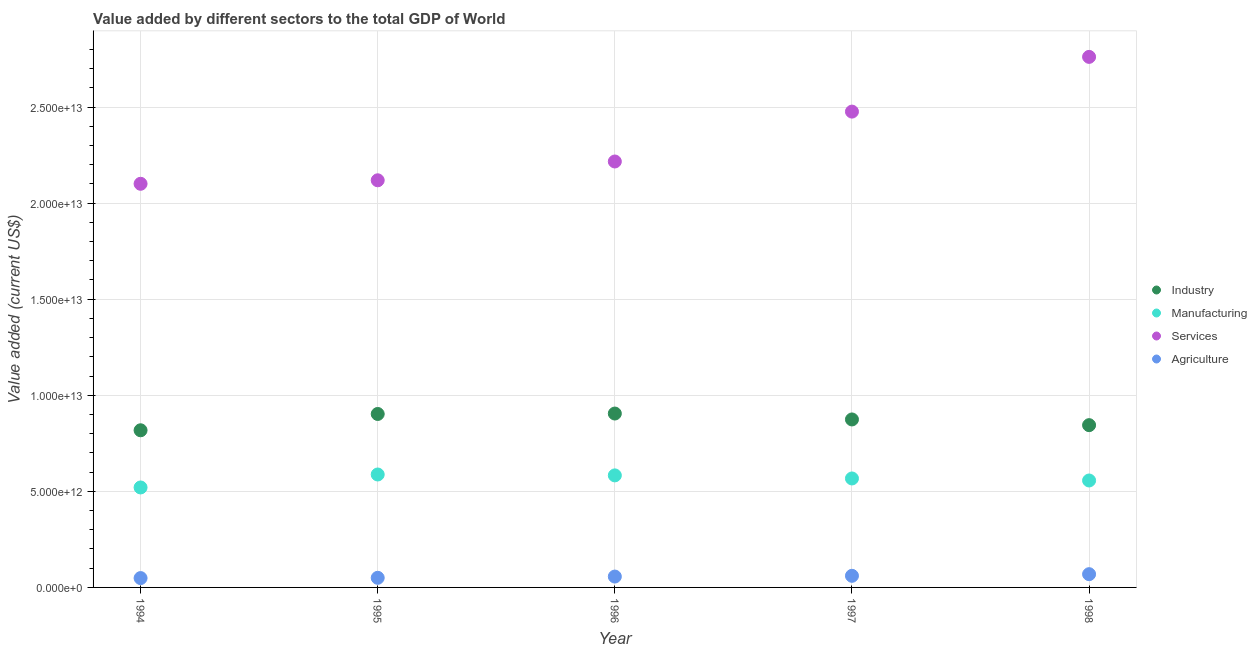How many different coloured dotlines are there?
Your answer should be very brief. 4. What is the value added by agricultural sector in 1995?
Your answer should be compact. 5.00e+11. Across all years, what is the maximum value added by services sector?
Provide a short and direct response. 2.76e+13. Across all years, what is the minimum value added by agricultural sector?
Offer a very short reply. 4.86e+11. In which year was the value added by manufacturing sector maximum?
Provide a short and direct response. 1995. In which year was the value added by manufacturing sector minimum?
Your response must be concise. 1994. What is the total value added by services sector in the graph?
Provide a short and direct response. 1.17e+14. What is the difference between the value added by manufacturing sector in 1994 and that in 1998?
Offer a terse response. -3.63e+11. What is the difference between the value added by agricultural sector in 1998 and the value added by services sector in 1995?
Provide a short and direct response. -2.05e+13. What is the average value added by manufacturing sector per year?
Make the answer very short. 5.63e+12. In the year 1996, what is the difference between the value added by industrial sector and value added by services sector?
Make the answer very short. -1.31e+13. What is the ratio of the value added by agricultural sector in 1994 to that in 1998?
Offer a terse response. 0.71. Is the value added by agricultural sector in 1997 less than that in 1998?
Offer a very short reply. Yes. What is the difference between the highest and the second highest value added by services sector?
Offer a very short reply. 2.85e+12. What is the difference between the highest and the lowest value added by agricultural sector?
Offer a very short reply. 2.03e+11. Is the value added by agricultural sector strictly less than the value added by services sector over the years?
Keep it short and to the point. Yes. What is the difference between two consecutive major ticks on the Y-axis?
Offer a very short reply. 5.00e+12. Are the values on the major ticks of Y-axis written in scientific E-notation?
Offer a very short reply. Yes. Does the graph contain any zero values?
Provide a succinct answer. No. Does the graph contain grids?
Your response must be concise. Yes. How are the legend labels stacked?
Your answer should be compact. Vertical. What is the title of the graph?
Your answer should be compact. Value added by different sectors to the total GDP of World. What is the label or title of the Y-axis?
Provide a short and direct response. Value added (current US$). What is the Value added (current US$) of Industry in 1994?
Offer a very short reply. 8.18e+12. What is the Value added (current US$) of Manufacturing in 1994?
Offer a terse response. 5.20e+12. What is the Value added (current US$) in Services in 1994?
Your answer should be compact. 2.10e+13. What is the Value added (current US$) of Agriculture in 1994?
Make the answer very short. 4.86e+11. What is the Value added (current US$) of Industry in 1995?
Give a very brief answer. 9.03e+12. What is the Value added (current US$) in Manufacturing in 1995?
Offer a terse response. 5.88e+12. What is the Value added (current US$) in Services in 1995?
Your answer should be very brief. 2.12e+13. What is the Value added (current US$) of Agriculture in 1995?
Keep it short and to the point. 5.00e+11. What is the Value added (current US$) of Industry in 1996?
Provide a short and direct response. 9.05e+12. What is the Value added (current US$) in Manufacturing in 1996?
Your answer should be very brief. 5.83e+12. What is the Value added (current US$) in Services in 1996?
Offer a very short reply. 2.22e+13. What is the Value added (current US$) in Agriculture in 1996?
Your answer should be very brief. 5.66e+11. What is the Value added (current US$) in Industry in 1997?
Give a very brief answer. 8.74e+12. What is the Value added (current US$) of Manufacturing in 1997?
Make the answer very short. 5.67e+12. What is the Value added (current US$) in Services in 1997?
Provide a succinct answer. 2.48e+13. What is the Value added (current US$) in Agriculture in 1997?
Offer a very short reply. 6.04e+11. What is the Value added (current US$) of Industry in 1998?
Ensure brevity in your answer.  8.45e+12. What is the Value added (current US$) in Manufacturing in 1998?
Your answer should be compact. 5.57e+12. What is the Value added (current US$) in Services in 1998?
Give a very brief answer. 2.76e+13. What is the Value added (current US$) in Agriculture in 1998?
Your response must be concise. 6.90e+11. Across all years, what is the maximum Value added (current US$) in Industry?
Your answer should be very brief. 9.05e+12. Across all years, what is the maximum Value added (current US$) in Manufacturing?
Provide a succinct answer. 5.88e+12. Across all years, what is the maximum Value added (current US$) of Services?
Your answer should be compact. 2.76e+13. Across all years, what is the maximum Value added (current US$) of Agriculture?
Provide a succinct answer. 6.90e+11. Across all years, what is the minimum Value added (current US$) in Industry?
Your answer should be compact. 8.18e+12. Across all years, what is the minimum Value added (current US$) of Manufacturing?
Ensure brevity in your answer.  5.20e+12. Across all years, what is the minimum Value added (current US$) in Services?
Your response must be concise. 2.10e+13. Across all years, what is the minimum Value added (current US$) in Agriculture?
Your response must be concise. 4.86e+11. What is the total Value added (current US$) of Industry in the graph?
Your answer should be very brief. 4.34e+13. What is the total Value added (current US$) of Manufacturing in the graph?
Your answer should be compact. 2.81e+13. What is the total Value added (current US$) in Services in the graph?
Your answer should be very brief. 1.17e+14. What is the total Value added (current US$) of Agriculture in the graph?
Offer a very short reply. 2.85e+12. What is the difference between the Value added (current US$) of Industry in 1994 and that in 1995?
Ensure brevity in your answer.  -8.49e+11. What is the difference between the Value added (current US$) in Manufacturing in 1994 and that in 1995?
Your response must be concise. -6.75e+11. What is the difference between the Value added (current US$) in Services in 1994 and that in 1995?
Offer a terse response. -1.82e+11. What is the difference between the Value added (current US$) in Agriculture in 1994 and that in 1995?
Offer a terse response. -1.42e+1. What is the difference between the Value added (current US$) in Industry in 1994 and that in 1996?
Your answer should be very brief. -8.71e+11. What is the difference between the Value added (current US$) of Manufacturing in 1994 and that in 1996?
Offer a very short reply. -6.28e+11. What is the difference between the Value added (current US$) of Services in 1994 and that in 1996?
Provide a succinct answer. -1.16e+12. What is the difference between the Value added (current US$) in Agriculture in 1994 and that in 1996?
Your answer should be very brief. -7.93e+1. What is the difference between the Value added (current US$) of Industry in 1994 and that in 1997?
Your answer should be compact. -5.64e+11. What is the difference between the Value added (current US$) in Manufacturing in 1994 and that in 1997?
Provide a succinct answer. -4.68e+11. What is the difference between the Value added (current US$) in Services in 1994 and that in 1997?
Your answer should be very brief. -3.76e+12. What is the difference between the Value added (current US$) of Agriculture in 1994 and that in 1997?
Give a very brief answer. -1.18e+11. What is the difference between the Value added (current US$) in Industry in 1994 and that in 1998?
Provide a short and direct response. -2.67e+11. What is the difference between the Value added (current US$) in Manufacturing in 1994 and that in 1998?
Provide a short and direct response. -3.63e+11. What is the difference between the Value added (current US$) in Services in 1994 and that in 1998?
Give a very brief answer. -6.60e+12. What is the difference between the Value added (current US$) in Agriculture in 1994 and that in 1998?
Keep it short and to the point. -2.03e+11. What is the difference between the Value added (current US$) of Industry in 1995 and that in 1996?
Give a very brief answer. -2.27e+1. What is the difference between the Value added (current US$) in Manufacturing in 1995 and that in 1996?
Your answer should be very brief. 4.64e+1. What is the difference between the Value added (current US$) of Services in 1995 and that in 1996?
Your answer should be very brief. -9.78e+11. What is the difference between the Value added (current US$) in Agriculture in 1995 and that in 1996?
Make the answer very short. -6.51e+1. What is the difference between the Value added (current US$) in Industry in 1995 and that in 1997?
Offer a terse response. 2.85e+11. What is the difference between the Value added (current US$) of Manufacturing in 1995 and that in 1997?
Give a very brief answer. 2.07e+11. What is the difference between the Value added (current US$) of Services in 1995 and that in 1997?
Make the answer very short. -3.57e+12. What is the difference between the Value added (current US$) in Agriculture in 1995 and that in 1997?
Your answer should be very brief. -1.04e+11. What is the difference between the Value added (current US$) in Industry in 1995 and that in 1998?
Offer a very short reply. 5.82e+11. What is the difference between the Value added (current US$) of Manufacturing in 1995 and that in 1998?
Offer a terse response. 3.12e+11. What is the difference between the Value added (current US$) of Services in 1995 and that in 1998?
Ensure brevity in your answer.  -6.42e+12. What is the difference between the Value added (current US$) of Agriculture in 1995 and that in 1998?
Keep it short and to the point. -1.89e+11. What is the difference between the Value added (current US$) of Industry in 1996 and that in 1997?
Offer a terse response. 3.08e+11. What is the difference between the Value added (current US$) in Manufacturing in 1996 and that in 1997?
Ensure brevity in your answer.  1.60e+11. What is the difference between the Value added (current US$) of Services in 1996 and that in 1997?
Keep it short and to the point. -2.60e+12. What is the difference between the Value added (current US$) in Agriculture in 1996 and that in 1997?
Provide a succinct answer. -3.88e+1. What is the difference between the Value added (current US$) in Industry in 1996 and that in 1998?
Offer a very short reply. 6.05e+11. What is the difference between the Value added (current US$) of Manufacturing in 1996 and that in 1998?
Ensure brevity in your answer.  2.66e+11. What is the difference between the Value added (current US$) of Services in 1996 and that in 1998?
Your answer should be very brief. -5.44e+12. What is the difference between the Value added (current US$) in Agriculture in 1996 and that in 1998?
Offer a terse response. -1.24e+11. What is the difference between the Value added (current US$) of Industry in 1997 and that in 1998?
Keep it short and to the point. 2.97e+11. What is the difference between the Value added (current US$) in Manufacturing in 1997 and that in 1998?
Provide a short and direct response. 1.05e+11. What is the difference between the Value added (current US$) in Services in 1997 and that in 1998?
Your answer should be compact. -2.85e+12. What is the difference between the Value added (current US$) of Agriculture in 1997 and that in 1998?
Give a very brief answer. -8.53e+1. What is the difference between the Value added (current US$) of Industry in 1994 and the Value added (current US$) of Manufacturing in 1995?
Ensure brevity in your answer.  2.30e+12. What is the difference between the Value added (current US$) of Industry in 1994 and the Value added (current US$) of Services in 1995?
Provide a succinct answer. -1.30e+13. What is the difference between the Value added (current US$) in Industry in 1994 and the Value added (current US$) in Agriculture in 1995?
Make the answer very short. 7.68e+12. What is the difference between the Value added (current US$) of Manufacturing in 1994 and the Value added (current US$) of Services in 1995?
Provide a succinct answer. -1.60e+13. What is the difference between the Value added (current US$) in Manufacturing in 1994 and the Value added (current US$) in Agriculture in 1995?
Keep it short and to the point. 4.70e+12. What is the difference between the Value added (current US$) of Services in 1994 and the Value added (current US$) of Agriculture in 1995?
Your answer should be compact. 2.05e+13. What is the difference between the Value added (current US$) in Industry in 1994 and the Value added (current US$) in Manufacturing in 1996?
Your answer should be very brief. 2.35e+12. What is the difference between the Value added (current US$) in Industry in 1994 and the Value added (current US$) in Services in 1996?
Your answer should be compact. -1.40e+13. What is the difference between the Value added (current US$) of Industry in 1994 and the Value added (current US$) of Agriculture in 1996?
Your response must be concise. 7.61e+12. What is the difference between the Value added (current US$) in Manufacturing in 1994 and the Value added (current US$) in Services in 1996?
Make the answer very short. -1.70e+13. What is the difference between the Value added (current US$) of Manufacturing in 1994 and the Value added (current US$) of Agriculture in 1996?
Keep it short and to the point. 4.64e+12. What is the difference between the Value added (current US$) in Services in 1994 and the Value added (current US$) in Agriculture in 1996?
Offer a terse response. 2.04e+13. What is the difference between the Value added (current US$) of Industry in 1994 and the Value added (current US$) of Manufacturing in 1997?
Provide a succinct answer. 2.51e+12. What is the difference between the Value added (current US$) in Industry in 1994 and the Value added (current US$) in Services in 1997?
Give a very brief answer. -1.66e+13. What is the difference between the Value added (current US$) of Industry in 1994 and the Value added (current US$) of Agriculture in 1997?
Give a very brief answer. 7.57e+12. What is the difference between the Value added (current US$) of Manufacturing in 1994 and the Value added (current US$) of Services in 1997?
Provide a succinct answer. -1.96e+13. What is the difference between the Value added (current US$) of Manufacturing in 1994 and the Value added (current US$) of Agriculture in 1997?
Provide a short and direct response. 4.60e+12. What is the difference between the Value added (current US$) of Services in 1994 and the Value added (current US$) of Agriculture in 1997?
Your response must be concise. 2.04e+13. What is the difference between the Value added (current US$) in Industry in 1994 and the Value added (current US$) in Manufacturing in 1998?
Keep it short and to the point. 2.61e+12. What is the difference between the Value added (current US$) in Industry in 1994 and the Value added (current US$) in Services in 1998?
Your response must be concise. -1.94e+13. What is the difference between the Value added (current US$) in Industry in 1994 and the Value added (current US$) in Agriculture in 1998?
Provide a short and direct response. 7.49e+12. What is the difference between the Value added (current US$) in Manufacturing in 1994 and the Value added (current US$) in Services in 1998?
Offer a terse response. -2.24e+13. What is the difference between the Value added (current US$) in Manufacturing in 1994 and the Value added (current US$) in Agriculture in 1998?
Ensure brevity in your answer.  4.51e+12. What is the difference between the Value added (current US$) of Services in 1994 and the Value added (current US$) of Agriculture in 1998?
Offer a very short reply. 2.03e+13. What is the difference between the Value added (current US$) in Industry in 1995 and the Value added (current US$) in Manufacturing in 1996?
Offer a terse response. 3.20e+12. What is the difference between the Value added (current US$) of Industry in 1995 and the Value added (current US$) of Services in 1996?
Provide a succinct answer. -1.31e+13. What is the difference between the Value added (current US$) of Industry in 1995 and the Value added (current US$) of Agriculture in 1996?
Ensure brevity in your answer.  8.46e+12. What is the difference between the Value added (current US$) in Manufacturing in 1995 and the Value added (current US$) in Services in 1996?
Offer a terse response. -1.63e+13. What is the difference between the Value added (current US$) of Manufacturing in 1995 and the Value added (current US$) of Agriculture in 1996?
Provide a succinct answer. 5.31e+12. What is the difference between the Value added (current US$) of Services in 1995 and the Value added (current US$) of Agriculture in 1996?
Your answer should be very brief. 2.06e+13. What is the difference between the Value added (current US$) of Industry in 1995 and the Value added (current US$) of Manufacturing in 1997?
Offer a very short reply. 3.36e+12. What is the difference between the Value added (current US$) of Industry in 1995 and the Value added (current US$) of Services in 1997?
Provide a succinct answer. -1.57e+13. What is the difference between the Value added (current US$) in Industry in 1995 and the Value added (current US$) in Agriculture in 1997?
Your answer should be very brief. 8.42e+12. What is the difference between the Value added (current US$) in Manufacturing in 1995 and the Value added (current US$) in Services in 1997?
Your answer should be compact. -1.89e+13. What is the difference between the Value added (current US$) in Manufacturing in 1995 and the Value added (current US$) in Agriculture in 1997?
Provide a short and direct response. 5.27e+12. What is the difference between the Value added (current US$) in Services in 1995 and the Value added (current US$) in Agriculture in 1997?
Make the answer very short. 2.06e+13. What is the difference between the Value added (current US$) of Industry in 1995 and the Value added (current US$) of Manufacturing in 1998?
Offer a terse response. 3.46e+12. What is the difference between the Value added (current US$) of Industry in 1995 and the Value added (current US$) of Services in 1998?
Your response must be concise. -1.86e+13. What is the difference between the Value added (current US$) of Industry in 1995 and the Value added (current US$) of Agriculture in 1998?
Ensure brevity in your answer.  8.34e+12. What is the difference between the Value added (current US$) in Manufacturing in 1995 and the Value added (current US$) in Services in 1998?
Ensure brevity in your answer.  -2.17e+13. What is the difference between the Value added (current US$) in Manufacturing in 1995 and the Value added (current US$) in Agriculture in 1998?
Give a very brief answer. 5.19e+12. What is the difference between the Value added (current US$) in Services in 1995 and the Value added (current US$) in Agriculture in 1998?
Make the answer very short. 2.05e+13. What is the difference between the Value added (current US$) in Industry in 1996 and the Value added (current US$) in Manufacturing in 1997?
Give a very brief answer. 3.38e+12. What is the difference between the Value added (current US$) in Industry in 1996 and the Value added (current US$) in Services in 1997?
Your answer should be very brief. -1.57e+13. What is the difference between the Value added (current US$) of Industry in 1996 and the Value added (current US$) of Agriculture in 1997?
Offer a terse response. 8.45e+12. What is the difference between the Value added (current US$) in Manufacturing in 1996 and the Value added (current US$) in Services in 1997?
Your answer should be very brief. -1.89e+13. What is the difference between the Value added (current US$) of Manufacturing in 1996 and the Value added (current US$) of Agriculture in 1997?
Your answer should be compact. 5.23e+12. What is the difference between the Value added (current US$) of Services in 1996 and the Value added (current US$) of Agriculture in 1997?
Offer a very short reply. 2.16e+13. What is the difference between the Value added (current US$) in Industry in 1996 and the Value added (current US$) in Manufacturing in 1998?
Provide a short and direct response. 3.48e+12. What is the difference between the Value added (current US$) of Industry in 1996 and the Value added (current US$) of Services in 1998?
Provide a succinct answer. -1.86e+13. What is the difference between the Value added (current US$) in Industry in 1996 and the Value added (current US$) in Agriculture in 1998?
Your answer should be compact. 8.36e+12. What is the difference between the Value added (current US$) of Manufacturing in 1996 and the Value added (current US$) of Services in 1998?
Your answer should be very brief. -2.18e+13. What is the difference between the Value added (current US$) in Manufacturing in 1996 and the Value added (current US$) in Agriculture in 1998?
Give a very brief answer. 5.14e+12. What is the difference between the Value added (current US$) of Services in 1996 and the Value added (current US$) of Agriculture in 1998?
Offer a very short reply. 2.15e+13. What is the difference between the Value added (current US$) of Industry in 1997 and the Value added (current US$) of Manufacturing in 1998?
Ensure brevity in your answer.  3.18e+12. What is the difference between the Value added (current US$) in Industry in 1997 and the Value added (current US$) in Services in 1998?
Provide a short and direct response. -1.89e+13. What is the difference between the Value added (current US$) in Industry in 1997 and the Value added (current US$) in Agriculture in 1998?
Your answer should be compact. 8.05e+12. What is the difference between the Value added (current US$) of Manufacturing in 1997 and the Value added (current US$) of Services in 1998?
Make the answer very short. -2.19e+13. What is the difference between the Value added (current US$) of Manufacturing in 1997 and the Value added (current US$) of Agriculture in 1998?
Provide a short and direct response. 4.98e+12. What is the difference between the Value added (current US$) of Services in 1997 and the Value added (current US$) of Agriculture in 1998?
Provide a succinct answer. 2.41e+13. What is the average Value added (current US$) of Industry per year?
Provide a short and direct response. 8.69e+12. What is the average Value added (current US$) in Manufacturing per year?
Your answer should be compact. 5.63e+12. What is the average Value added (current US$) in Services per year?
Make the answer very short. 2.33e+13. What is the average Value added (current US$) of Agriculture per year?
Your answer should be compact. 5.69e+11. In the year 1994, what is the difference between the Value added (current US$) of Industry and Value added (current US$) of Manufacturing?
Your answer should be compact. 2.98e+12. In the year 1994, what is the difference between the Value added (current US$) of Industry and Value added (current US$) of Services?
Provide a short and direct response. -1.28e+13. In the year 1994, what is the difference between the Value added (current US$) in Industry and Value added (current US$) in Agriculture?
Keep it short and to the point. 7.69e+12. In the year 1994, what is the difference between the Value added (current US$) of Manufacturing and Value added (current US$) of Services?
Your answer should be very brief. -1.58e+13. In the year 1994, what is the difference between the Value added (current US$) in Manufacturing and Value added (current US$) in Agriculture?
Ensure brevity in your answer.  4.72e+12. In the year 1994, what is the difference between the Value added (current US$) in Services and Value added (current US$) in Agriculture?
Offer a terse response. 2.05e+13. In the year 1995, what is the difference between the Value added (current US$) in Industry and Value added (current US$) in Manufacturing?
Give a very brief answer. 3.15e+12. In the year 1995, what is the difference between the Value added (current US$) in Industry and Value added (current US$) in Services?
Offer a very short reply. -1.22e+13. In the year 1995, what is the difference between the Value added (current US$) of Industry and Value added (current US$) of Agriculture?
Give a very brief answer. 8.53e+12. In the year 1995, what is the difference between the Value added (current US$) of Manufacturing and Value added (current US$) of Services?
Offer a terse response. -1.53e+13. In the year 1995, what is the difference between the Value added (current US$) in Manufacturing and Value added (current US$) in Agriculture?
Keep it short and to the point. 5.38e+12. In the year 1995, what is the difference between the Value added (current US$) in Services and Value added (current US$) in Agriculture?
Ensure brevity in your answer.  2.07e+13. In the year 1996, what is the difference between the Value added (current US$) in Industry and Value added (current US$) in Manufacturing?
Give a very brief answer. 3.22e+12. In the year 1996, what is the difference between the Value added (current US$) of Industry and Value added (current US$) of Services?
Your answer should be compact. -1.31e+13. In the year 1996, what is the difference between the Value added (current US$) of Industry and Value added (current US$) of Agriculture?
Ensure brevity in your answer.  8.48e+12. In the year 1996, what is the difference between the Value added (current US$) of Manufacturing and Value added (current US$) of Services?
Your response must be concise. -1.63e+13. In the year 1996, what is the difference between the Value added (current US$) in Manufacturing and Value added (current US$) in Agriculture?
Your response must be concise. 5.27e+12. In the year 1996, what is the difference between the Value added (current US$) of Services and Value added (current US$) of Agriculture?
Offer a terse response. 2.16e+13. In the year 1997, what is the difference between the Value added (current US$) of Industry and Value added (current US$) of Manufacturing?
Give a very brief answer. 3.07e+12. In the year 1997, what is the difference between the Value added (current US$) of Industry and Value added (current US$) of Services?
Offer a terse response. -1.60e+13. In the year 1997, what is the difference between the Value added (current US$) in Industry and Value added (current US$) in Agriculture?
Give a very brief answer. 8.14e+12. In the year 1997, what is the difference between the Value added (current US$) in Manufacturing and Value added (current US$) in Services?
Make the answer very short. -1.91e+13. In the year 1997, what is the difference between the Value added (current US$) in Manufacturing and Value added (current US$) in Agriculture?
Your answer should be compact. 5.07e+12. In the year 1997, what is the difference between the Value added (current US$) in Services and Value added (current US$) in Agriculture?
Your answer should be compact. 2.42e+13. In the year 1998, what is the difference between the Value added (current US$) of Industry and Value added (current US$) of Manufacturing?
Provide a short and direct response. 2.88e+12. In the year 1998, what is the difference between the Value added (current US$) in Industry and Value added (current US$) in Services?
Keep it short and to the point. -1.92e+13. In the year 1998, what is the difference between the Value added (current US$) of Industry and Value added (current US$) of Agriculture?
Keep it short and to the point. 7.76e+12. In the year 1998, what is the difference between the Value added (current US$) in Manufacturing and Value added (current US$) in Services?
Your answer should be very brief. -2.20e+13. In the year 1998, what is the difference between the Value added (current US$) of Manufacturing and Value added (current US$) of Agriculture?
Ensure brevity in your answer.  4.88e+12. In the year 1998, what is the difference between the Value added (current US$) in Services and Value added (current US$) in Agriculture?
Give a very brief answer. 2.69e+13. What is the ratio of the Value added (current US$) of Industry in 1994 to that in 1995?
Provide a short and direct response. 0.91. What is the ratio of the Value added (current US$) of Manufacturing in 1994 to that in 1995?
Keep it short and to the point. 0.89. What is the ratio of the Value added (current US$) in Services in 1994 to that in 1995?
Offer a very short reply. 0.99. What is the ratio of the Value added (current US$) of Agriculture in 1994 to that in 1995?
Ensure brevity in your answer.  0.97. What is the ratio of the Value added (current US$) of Industry in 1994 to that in 1996?
Give a very brief answer. 0.9. What is the ratio of the Value added (current US$) in Manufacturing in 1994 to that in 1996?
Provide a succinct answer. 0.89. What is the ratio of the Value added (current US$) of Services in 1994 to that in 1996?
Provide a succinct answer. 0.95. What is the ratio of the Value added (current US$) in Agriculture in 1994 to that in 1996?
Your answer should be compact. 0.86. What is the ratio of the Value added (current US$) of Industry in 1994 to that in 1997?
Provide a short and direct response. 0.94. What is the ratio of the Value added (current US$) in Manufacturing in 1994 to that in 1997?
Keep it short and to the point. 0.92. What is the ratio of the Value added (current US$) in Services in 1994 to that in 1997?
Provide a succinct answer. 0.85. What is the ratio of the Value added (current US$) in Agriculture in 1994 to that in 1997?
Your answer should be very brief. 0.8. What is the ratio of the Value added (current US$) in Industry in 1994 to that in 1998?
Offer a terse response. 0.97. What is the ratio of the Value added (current US$) in Manufacturing in 1994 to that in 1998?
Ensure brevity in your answer.  0.93. What is the ratio of the Value added (current US$) in Services in 1994 to that in 1998?
Your answer should be very brief. 0.76. What is the ratio of the Value added (current US$) in Agriculture in 1994 to that in 1998?
Your answer should be very brief. 0.71. What is the ratio of the Value added (current US$) in Services in 1995 to that in 1996?
Keep it short and to the point. 0.96. What is the ratio of the Value added (current US$) of Agriculture in 1995 to that in 1996?
Ensure brevity in your answer.  0.89. What is the ratio of the Value added (current US$) in Industry in 1995 to that in 1997?
Provide a short and direct response. 1.03. What is the ratio of the Value added (current US$) of Manufacturing in 1995 to that in 1997?
Keep it short and to the point. 1.04. What is the ratio of the Value added (current US$) in Services in 1995 to that in 1997?
Your answer should be compact. 0.86. What is the ratio of the Value added (current US$) in Agriculture in 1995 to that in 1997?
Offer a very short reply. 0.83. What is the ratio of the Value added (current US$) in Industry in 1995 to that in 1998?
Keep it short and to the point. 1.07. What is the ratio of the Value added (current US$) of Manufacturing in 1995 to that in 1998?
Offer a very short reply. 1.06. What is the ratio of the Value added (current US$) of Services in 1995 to that in 1998?
Your response must be concise. 0.77. What is the ratio of the Value added (current US$) in Agriculture in 1995 to that in 1998?
Your response must be concise. 0.73. What is the ratio of the Value added (current US$) in Industry in 1996 to that in 1997?
Make the answer very short. 1.04. What is the ratio of the Value added (current US$) of Manufacturing in 1996 to that in 1997?
Your answer should be compact. 1.03. What is the ratio of the Value added (current US$) of Services in 1996 to that in 1997?
Make the answer very short. 0.9. What is the ratio of the Value added (current US$) of Agriculture in 1996 to that in 1997?
Your answer should be compact. 0.94. What is the ratio of the Value added (current US$) of Industry in 1996 to that in 1998?
Your response must be concise. 1.07. What is the ratio of the Value added (current US$) in Manufacturing in 1996 to that in 1998?
Provide a short and direct response. 1.05. What is the ratio of the Value added (current US$) of Services in 1996 to that in 1998?
Give a very brief answer. 0.8. What is the ratio of the Value added (current US$) in Agriculture in 1996 to that in 1998?
Offer a very short reply. 0.82. What is the ratio of the Value added (current US$) of Industry in 1997 to that in 1998?
Offer a terse response. 1.04. What is the ratio of the Value added (current US$) of Manufacturing in 1997 to that in 1998?
Make the answer very short. 1.02. What is the ratio of the Value added (current US$) in Services in 1997 to that in 1998?
Make the answer very short. 0.9. What is the ratio of the Value added (current US$) in Agriculture in 1997 to that in 1998?
Offer a terse response. 0.88. What is the difference between the highest and the second highest Value added (current US$) of Industry?
Make the answer very short. 2.27e+1. What is the difference between the highest and the second highest Value added (current US$) in Manufacturing?
Ensure brevity in your answer.  4.64e+1. What is the difference between the highest and the second highest Value added (current US$) of Services?
Make the answer very short. 2.85e+12. What is the difference between the highest and the second highest Value added (current US$) in Agriculture?
Your response must be concise. 8.53e+1. What is the difference between the highest and the lowest Value added (current US$) in Industry?
Offer a terse response. 8.71e+11. What is the difference between the highest and the lowest Value added (current US$) in Manufacturing?
Give a very brief answer. 6.75e+11. What is the difference between the highest and the lowest Value added (current US$) of Services?
Provide a succinct answer. 6.60e+12. What is the difference between the highest and the lowest Value added (current US$) in Agriculture?
Your answer should be very brief. 2.03e+11. 